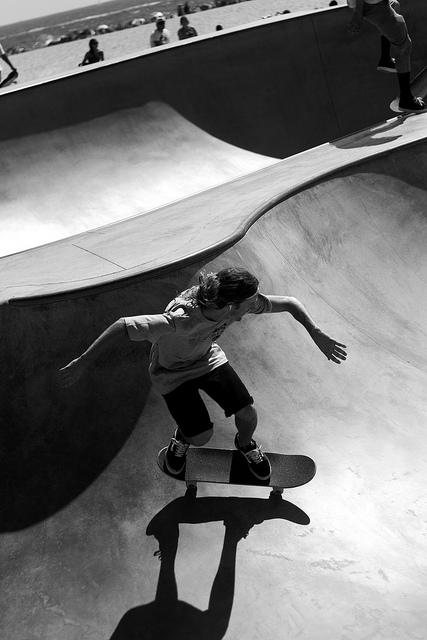Does the rider have short hair?
Write a very short answer. No. What sport is shown here?
Short answer required. Skateboarding. Is he surfing?
Be succinct. No. 